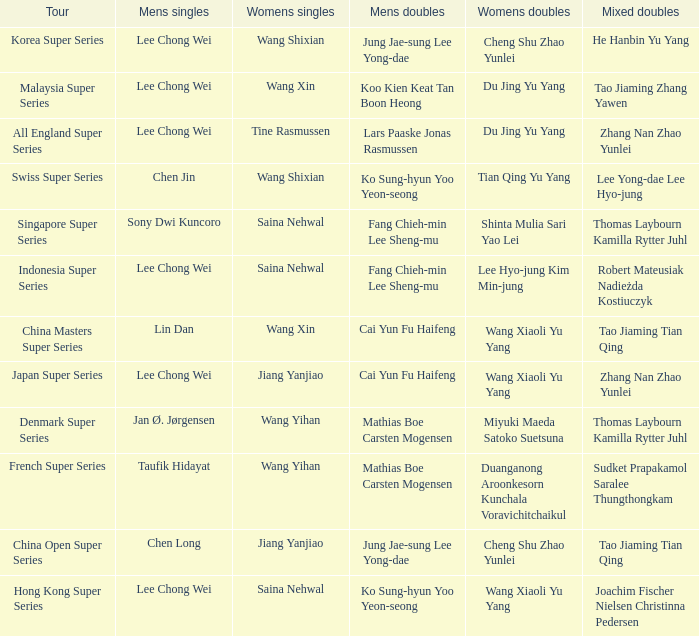In the korea super series tour, who makes up the mixed doubles team? He Hanbin Yu Yang. 